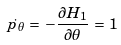<formula> <loc_0><loc_0><loc_500><loc_500>\dot { p _ { \theta } } \, = \, - \frac { \partial H _ { 1 } } { \partial \theta } \, = \, 1</formula> 